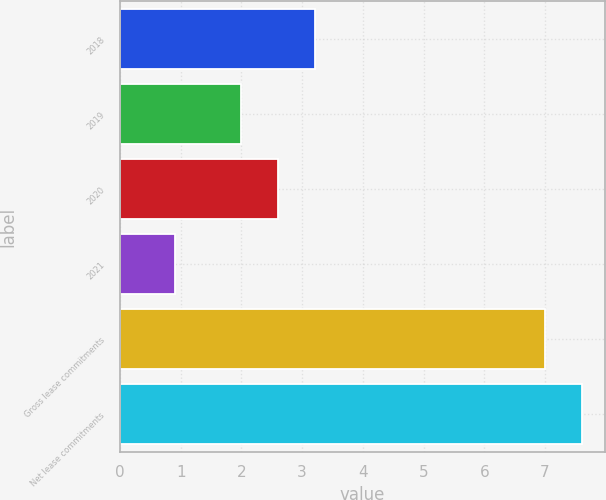<chart> <loc_0><loc_0><loc_500><loc_500><bar_chart><fcel>2018<fcel>2019<fcel>2020<fcel>2021<fcel>Gross lease commitments<fcel>Net lease commitments<nl><fcel>3.22<fcel>2<fcel>2.61<fcel>0.9<fcel>7<fcel>7.61<nl></chart> 